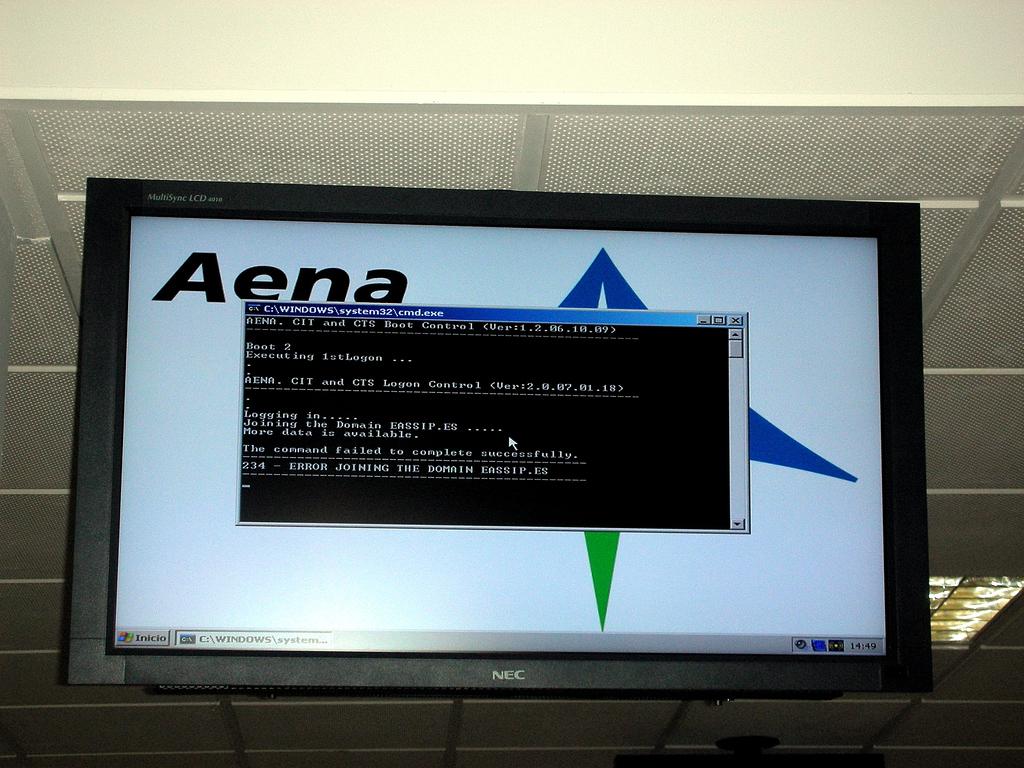What time is it on the computer?
Give a very brief answer. Unanswerable. What company logo is being used as the wallpaper on the computer screen?
Provide a short and direct response. Aena. 